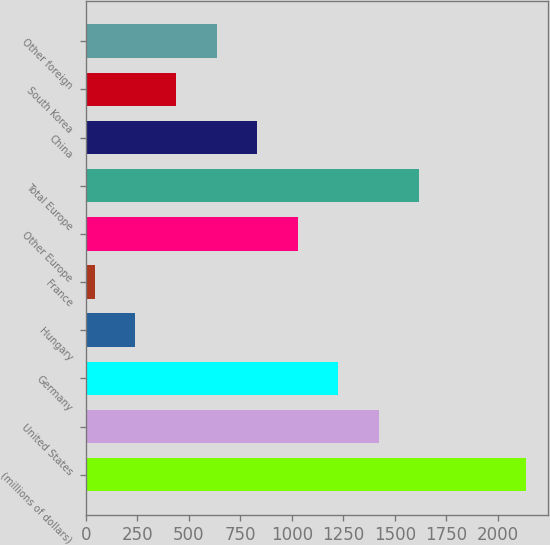<chart> <loc_0><loc_0><loc_500><loc_500><bar_chart><fcel>(millions of dollars)<fcel>United States<fcel>Germany<fcel>Hungary<fcel>France<fcel>Other Europe<fcel>Total Europe<fcel>China<fcel>South Korea<fcel>Other foreign<nl><fcel>2136.26<fcel>1422.42<fcel>1225.56<fcel>241.26<fcel>44.4<fcel>1028.7<fcel>1619.28<fcel>831.84<fcel>438.12<fcel>634.98<nl></chart> 